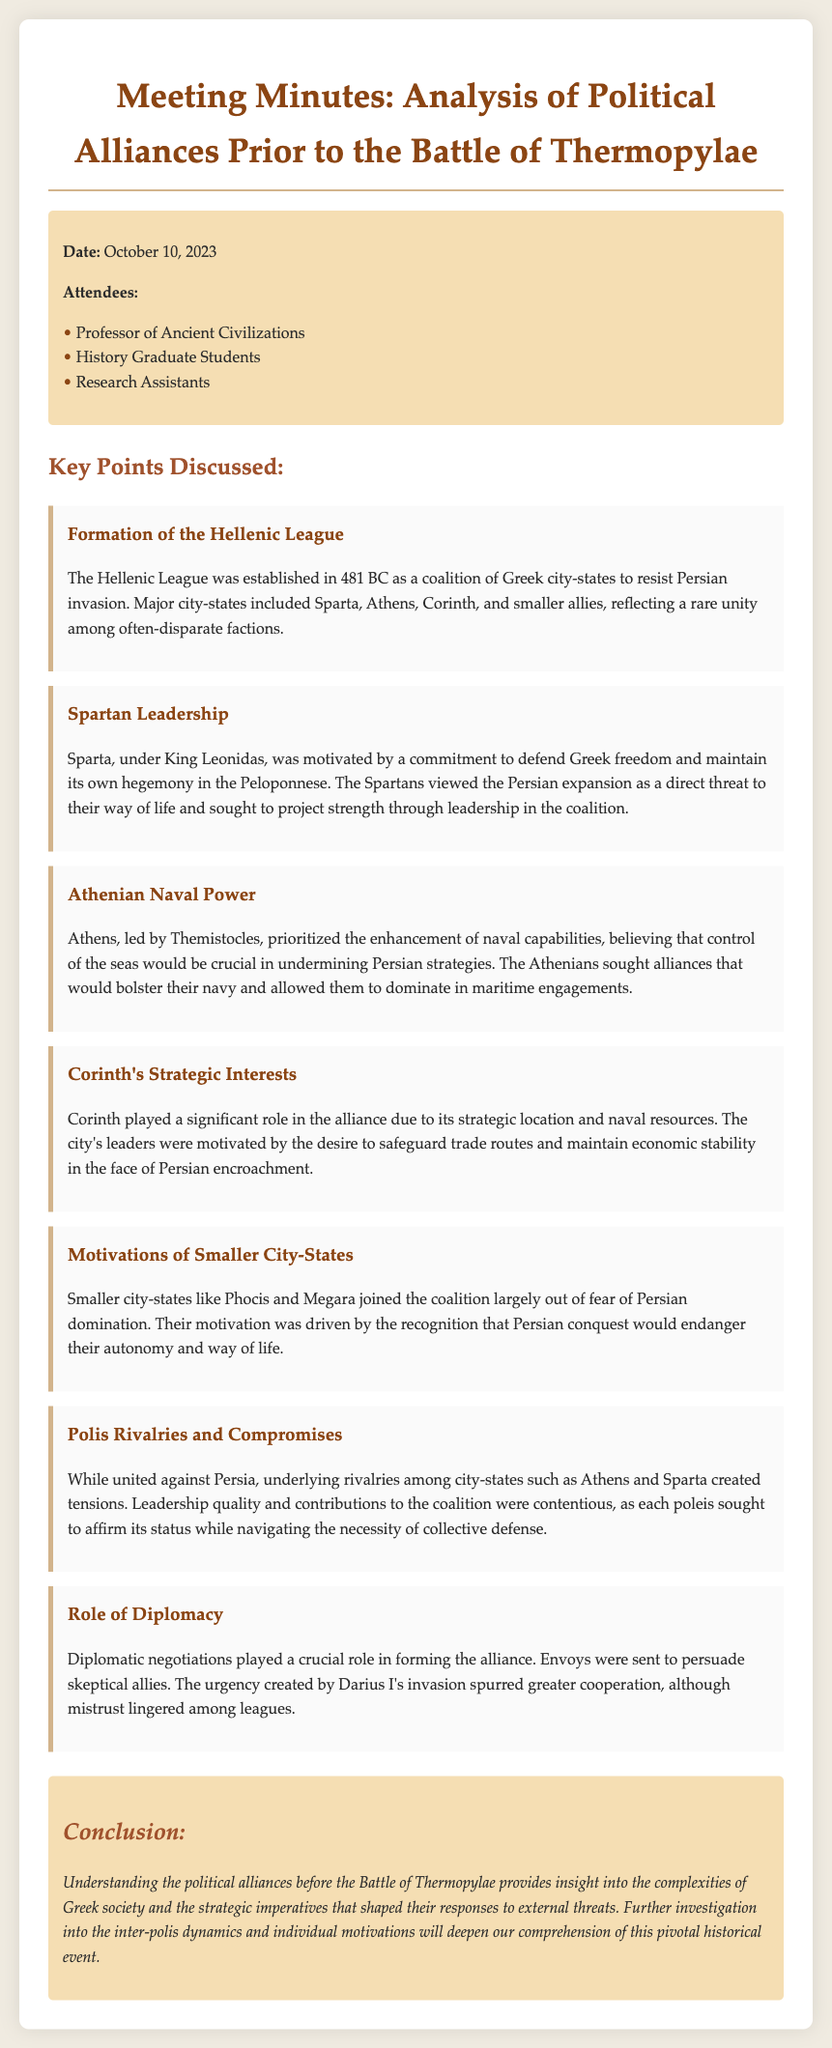What year was the Hellenic League established? The document states that the Hellenic League was established in 481 BC.
Answer: 481 BC Who was the king of Sparta during the formation of the alliances? The document names King Leonidas as the leader of Sparta.
Answer: King Leonidas What was the primary motivation of the Athenians according to the document? The document mentions that Athens prioritized the enhancement of naval capabilities.
Answer: Naval capabilities Which city-state played a significant role due to its strategic location? The document indicates that Corinth played a significant role due to its strategic location.
Answer: Corinth What were the smaller city-states motivated by? The document states that smaller city-states joined the coalition out of fear of Persian domination.
Answer: Fear of Persian domination What kind of rivalries existed among the city-states? The document describes underlying rivalries among city-states, particularly between Athens and Sparta.
Answer: Underlying rivalries When was the meeting held to discuss these alliances? The document provides the date of the meeting as October 10, 2023.
Answer: October 10, 2023 What role did diplomacy play in forming the alliance? The document emphasizes that diplomatic negotiations were crucial in forming the alliance.
Answer: Crucial 